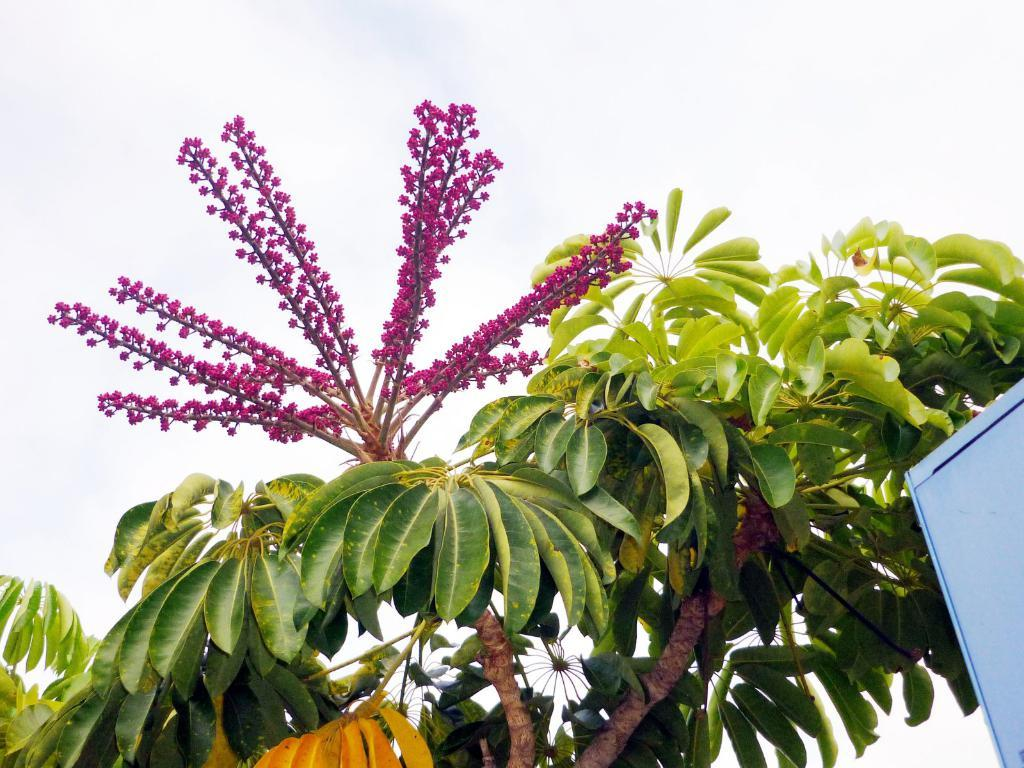What type of flowers are in the middle of the image? There are small pink flowers in the middle of the image. What is located at the bottom of the image? There is a tree with green leaves at the bottom of the image. What color is the box on the right side of the image? The box on the right side of the image is blue. What type of pencil can be seen in the image? There is no pencil present in the image. Is there a pot of water visible in the image? There is no pot or water present in the image. 